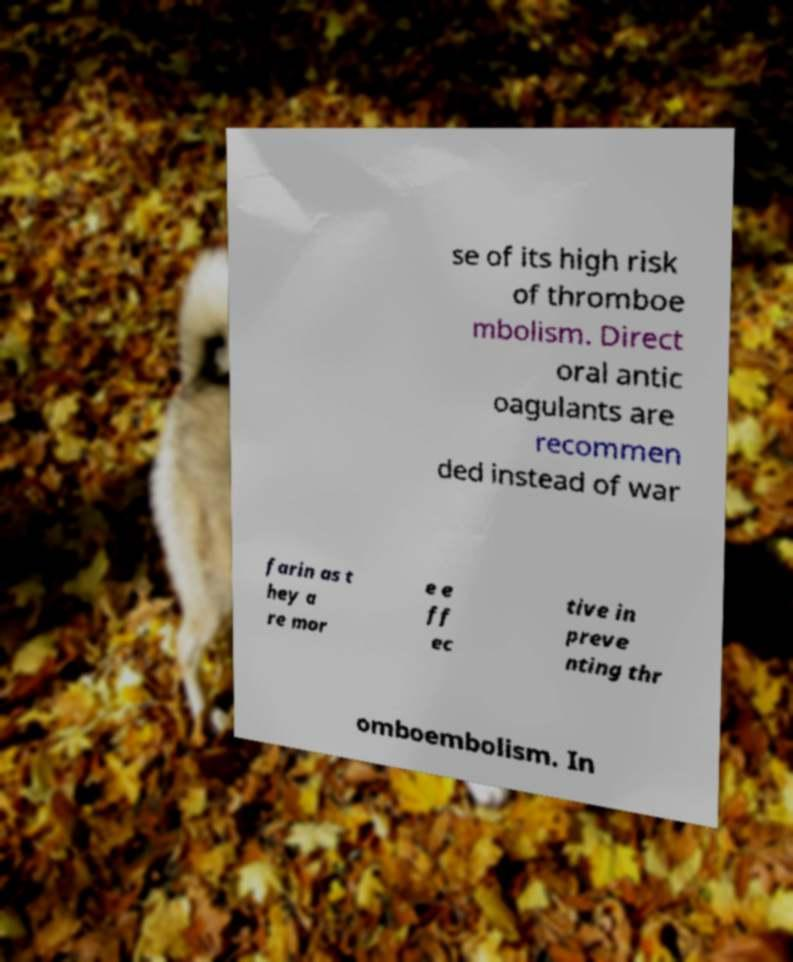For documentation purposes, I need the text within this image transcribed. Could you provide that? se of its high risk of thromboe mbolism. Direct oral antic oagulants are recommen ded instead of war farin as t hey a re mor e e ff ec tive in preve nting thr omboembolism. In 